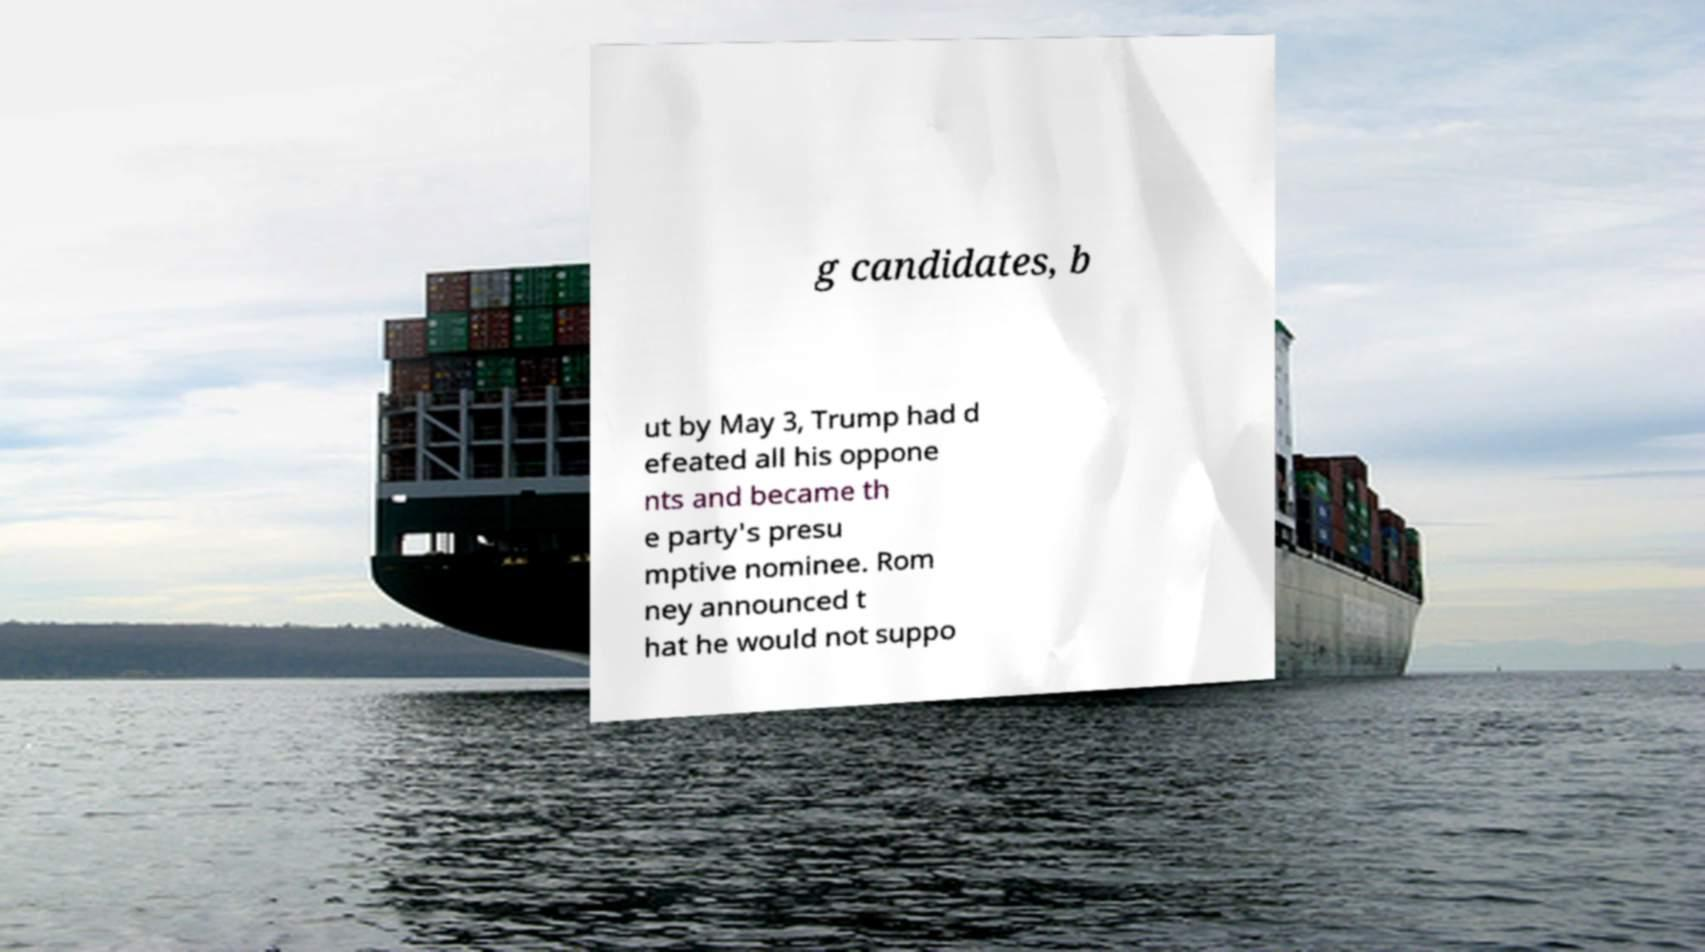There's text embedded in this image that I need extracted. Can you transcribe it verbatim? g candidates, b ut by May 3, Trump had d efeated all his oppone nts and became th e party's presu mptive nominee. Rom ney announced t hat he would not suppo 